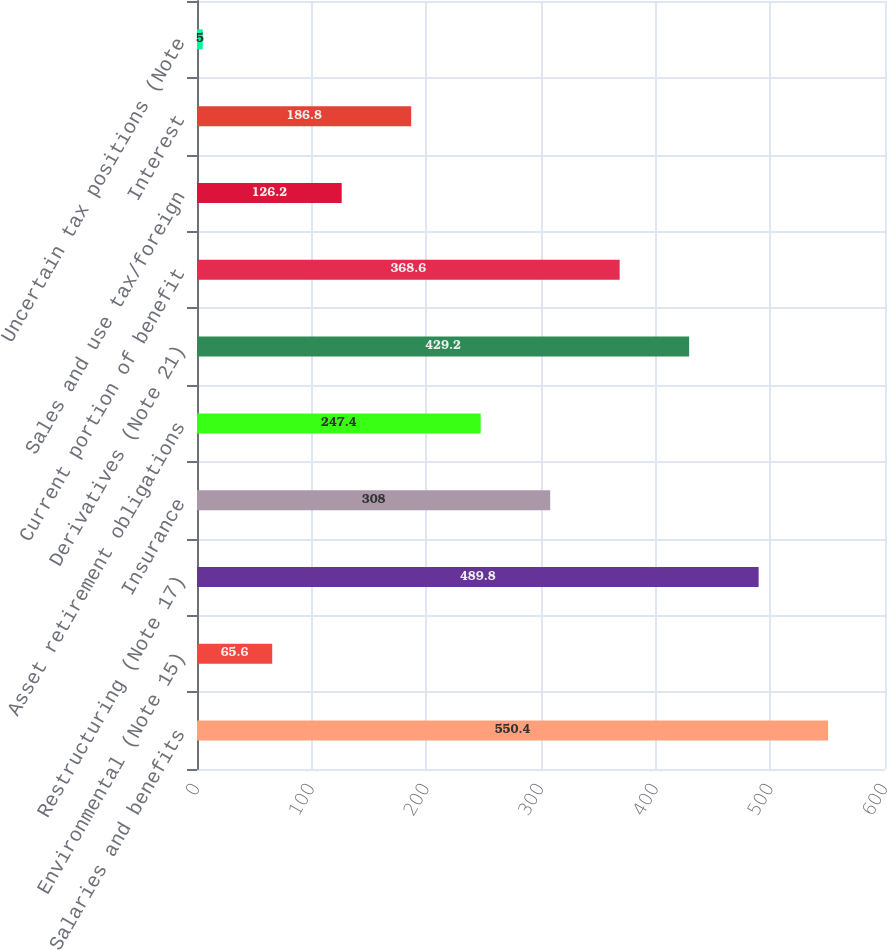<chart> <loc_0><loc_0><loc_500><loc_500><bar_chart><fcel>Salaries and benefits<fcel>Environmental (Note 15)<fcel>Restructuring (Note 17)<fcel>Insurance<fcel>Asset retirement obligations<fcel>Derivatives (Note 21)<fcel>Current portion of benefit<fcel>Sales and use tax/foreign<fcel>Interest<fcel>Uncertain tax positions (Note<nl><fcel>550.4<fcel>65.6<fcel>489.8<fcel>308<fcel>247.4<fcel>429.2<fcel>368.6<fcel>126.2<fcel>186.8<fcel>5<nl></chart> 